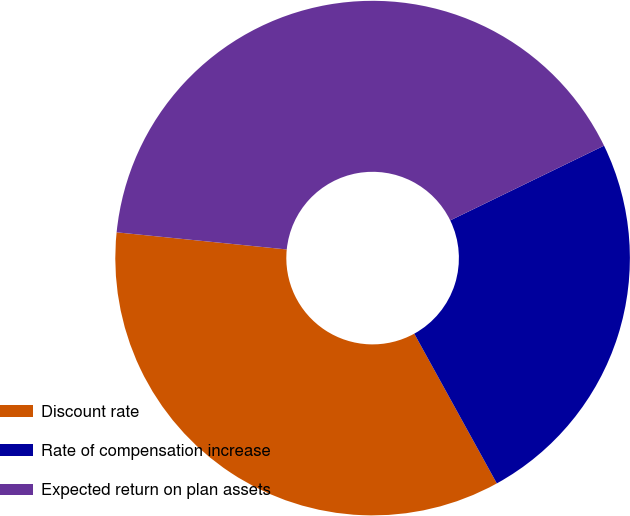Convert chart. <chart><loc_0><loc_0><loc_500><loc_500><pie_chart><fcel>Discount rate<fcel>Rate of compensation increase<fcel>Expected return on plan assets<nl><fcel>34.62%<fcel>24.18%<fcel>41.21%<nl></chart> 